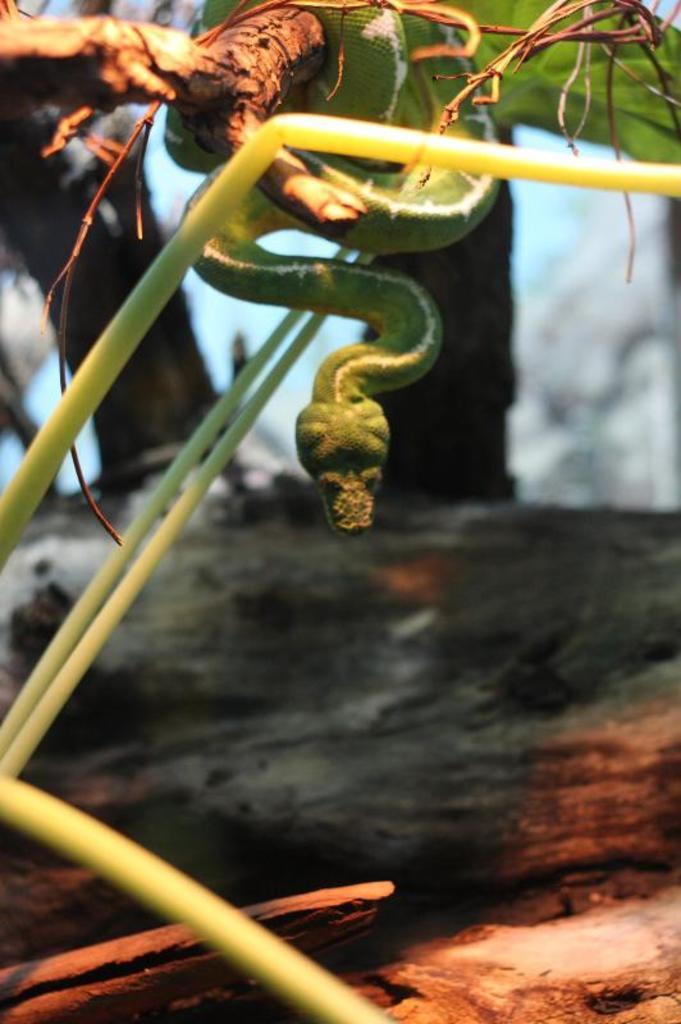What is located in the foreground of the image? There are plants in the foreground of the image. What can be seen at the top of the image? There is a snake at the top of the image. What type of vegetation is visible in the background of the image? There are trees in the background of the image. How does the snake measure the plants in the image? There is no indication in the image that the snake is measuring the plants, and snakes do not have the ability to measure objects. 